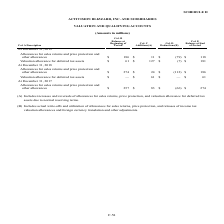According to Activision Blizzard's financial document, What was the Valuation allowance for deferred tax assets at the beginning of the period of 2019? According to the financial document, $61 (in millions). The relevant text states: "Valuation allowance for deferred tax assets $ 61 $ 127 $ (7) $ 181..." Also, What was the Valuation allowance for deferred tax assets at the end of the period of 2019? According to the financial document, $181 (in millions). The relevant text states: "owance for deferred tax assets $ 61 $ 127 $ (7) $ 181..." Also, What was the Allowances for sales returns and price protection and other allowances at the beginning of the period in 2018? According to the financial document, $274 (in millions). The relevant text states: "turns and price protection and other allowances $ 274 $ 24 $ (112) $ 186..." Also, can you calculate: What was the change in Valuation allowance for deferred tax assets between 2018 and 2019? Based on the calculation: $181-$61, the result is 120 (in millions). This is based on the information: "owance for deferred tax assets $ 61 $ 127 $ (7) $ 181 Valuation allowance for deferred tax assets $ 61 $ 127 $ (7) $ 181..." The key data points involved are: 181, 61. Also, can you calculate: What was the sum of Col. C Additions in 2018? Based on the calculation: $24+$61, the result is 85 (in millions). This is based on the information: "and price protection and other allowances $ 274 $ 24 $ (112) $ 186 Valuation allowance for deferred tax assets $ 61 $ 127 $ (7) $ 181..." The key data points involved are: 24, 61. Also, can you calculate: What was the sum of balances at the end of the period in 2019? Based on the calculation: $118+$181, the result is 299 (in millions). This is based on the information: "otection and other allowances $ 186 $ 11 $ (79) $ 118 owance for deferred tax assets $ 61 $ 127 $ (7) $ 181..." The key data points involved are: 118, 181. 